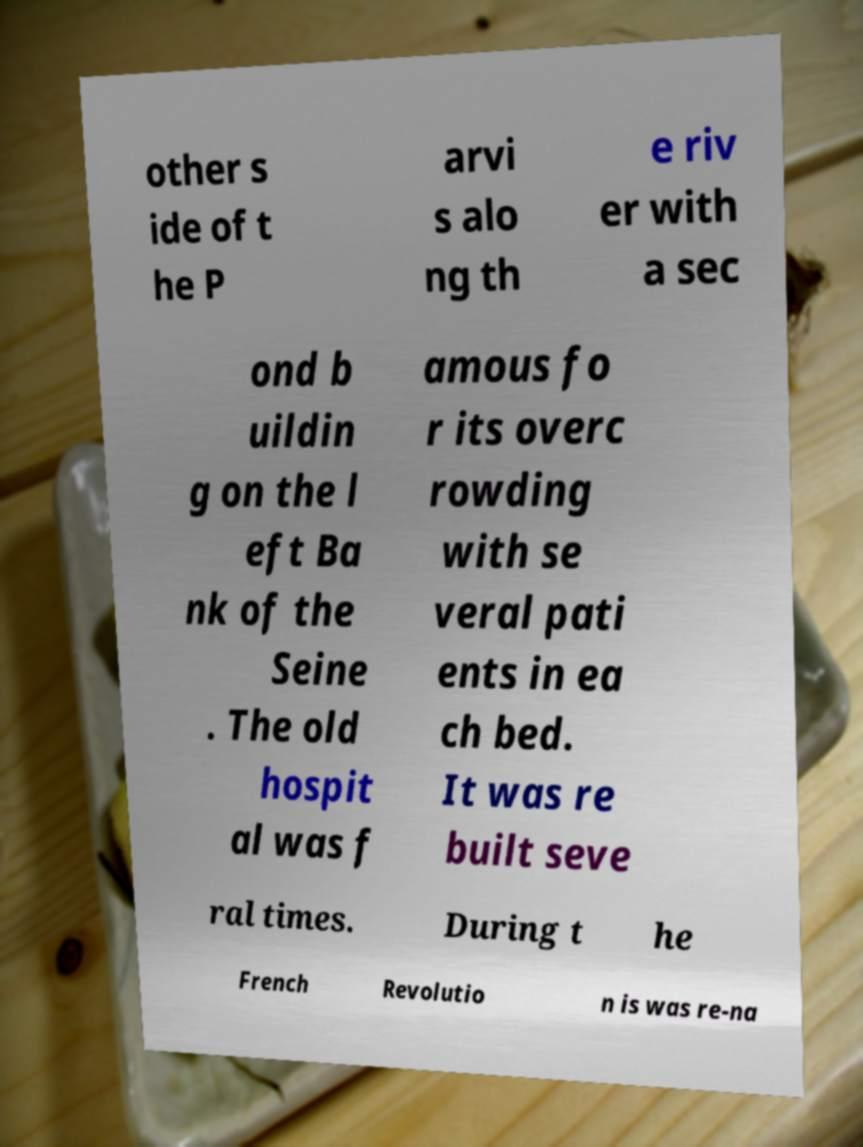Please identify and transcribe the text found in this image. other s ide of t he P arvi s alo ng th e riv er with a sec ond b uildin g on the l eft Ba nk of the Seine . The old hospit al was f amous fo r its overc rowding with se veral pati ents in ea ch bed. It was re built seve ral times. During t he French Revolutio n is was re-na 